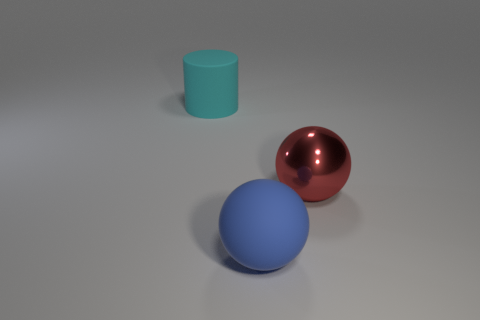Add 2 small cyan things. How many objects exist? 5 Subtract all cylinders. How many objects are left? 2 Subtract all cyan matte cylinders. Subtract all red spheres. How many objects are left? 1 Add 2 blue objects. How many blue objects are left? 3 Add 1 large cyan cylinders. How many large cyan cylinders exist? 2 Subtract 0 blue cubes. How many objects are left? 3 